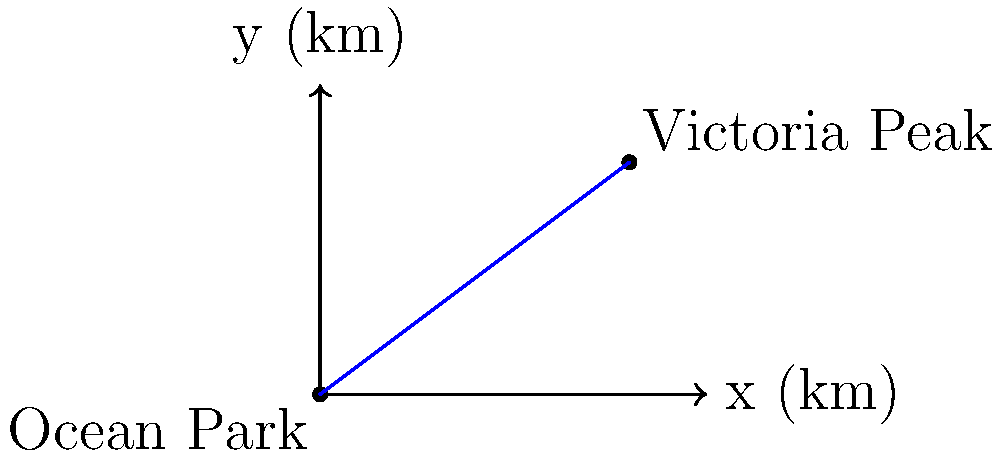In "A Step into the Past," two iconic Hong Kong locations, Ocean Park and Victoria Peak, are featured prominently. On a map, Ocean Park is located at coordinates (0,0) and Victoria Peak at (8,6), where each unit represents 1 kilometer. Calculate the straight-line distance between these two locations. To find the straight-line distance between two points, we can use the distance formula derived from the Pythagorean theorem:

$$d = \sqrt{(x_2 - x_1)^2 + (y_2 - y_1)^2}$$

Where $(x_1, y_1)$ is Ocean Park (0,0) and $(x_2, y_2)$ is Victoria Peak (8,6).

Step 1: Substitute the values into the formula:
$$d = \sqrt{(8 - 0)^2 + (6 - 0)^2}$$

Step 2: Simplify inside the parentheses:
$$d = \sqrt{8^2 + 6^2}$$

Step 3: Calculate the squares:
$$d = \sqrt{64 + 36}$$

Step 4: Add under the square root:
$$d = \sqrt{100}$$

Step 5: Simplify the square root:
$$d = 10$$

Therefore, the straight-line distance between Ocean Park and Victoria Peak is 10 kilometers.
Answer: 10 km 